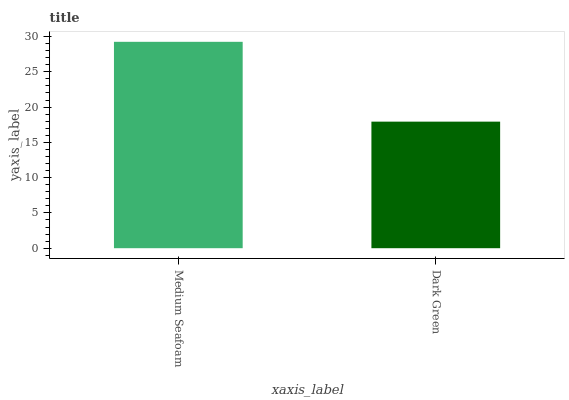Is Dark Green the minimum?
Answer yes or no. Yes. Is Medium Seafoam the maximum?
Answer yes or no. Yes. Is Dark Green the maximum?
Answer yes or no. No. Is Medium Seafoam greater than Dark Green?
Answer yes or no. Yes. Is Dark Green less than Medium Seafoam?
Answer yes or no. Yes. Is Dark Green greater than Medium Seafoam?
Answer yes or no. No. Is Medium Seafoam less than Dark Green?
Answer yes or no. No. Is Medium Seafoam the high median?
Answer yes or no. Yes. Is Dark Green the low median?
Answer yes or no. Yes. Is Dark Green the high median?
Answer yes or no. No. Is Medium Seafoam the low median?
Answer yes or no. No. 